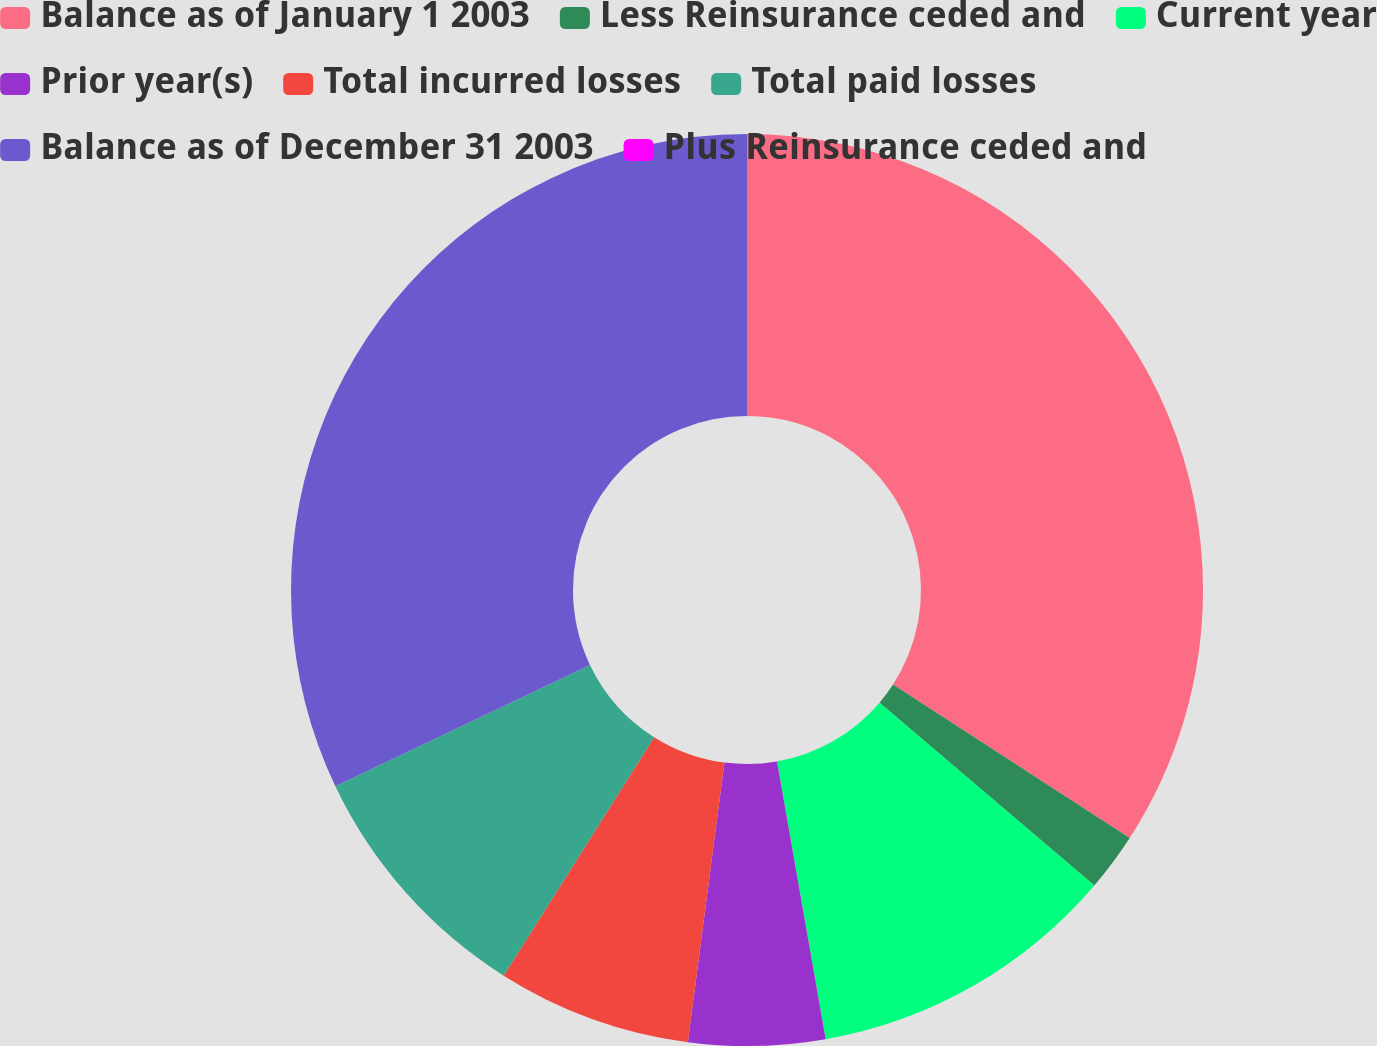Convert chart to OTSL. <chart><loc_0><loc_0><loc_500><loc_500><pie_chart><fcel>Balance as of January 1 2003<fcel>Less Reinsurance ceded and<fcel>Current year<fcel>Prior year(s)<fcel>Total incurred losses<fcel>Total paid losses<fcel>Balance as of December 31 2003<fcel>Plus Reinsurance ceded and<nl><fcel>34.15%<fcel>2.07%<fcel>11.02%<fcel>4.83%<fcel>6.89%<fcel>8.96%<fcel>32.08%<fcel>0.0%<nl></chart> 